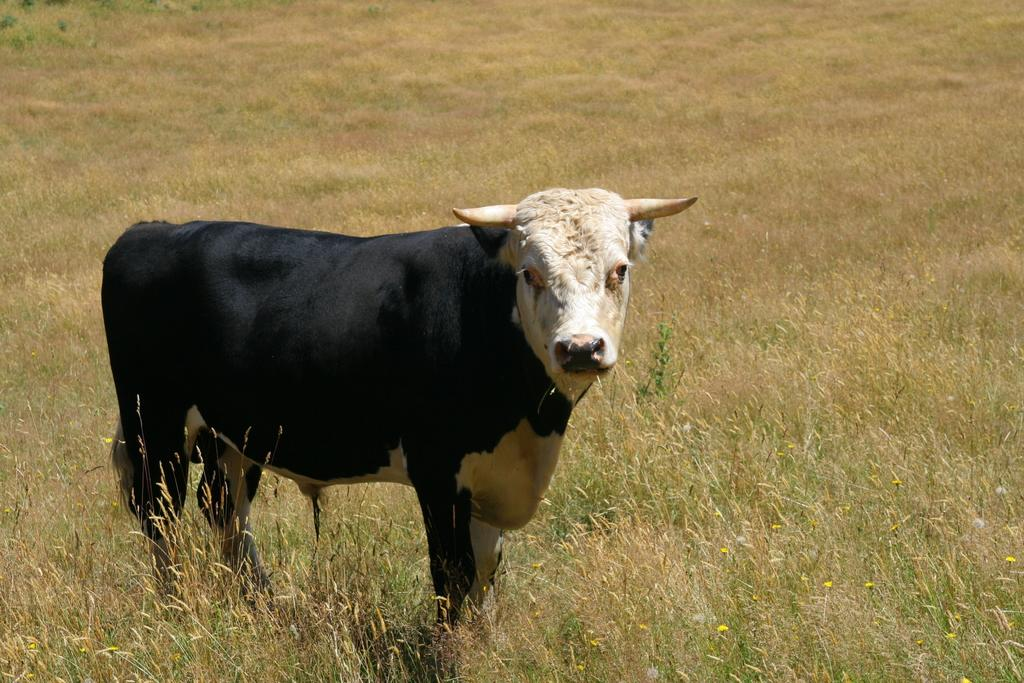What type of animal is present in the image? There is an animal in the image. What type of vegetation can be seen in the image? There is grass and flowers in the image. What type of dinner is being served on the edge of the image? There is no dinner or edge present in the image; it features an animal and vegetation. 